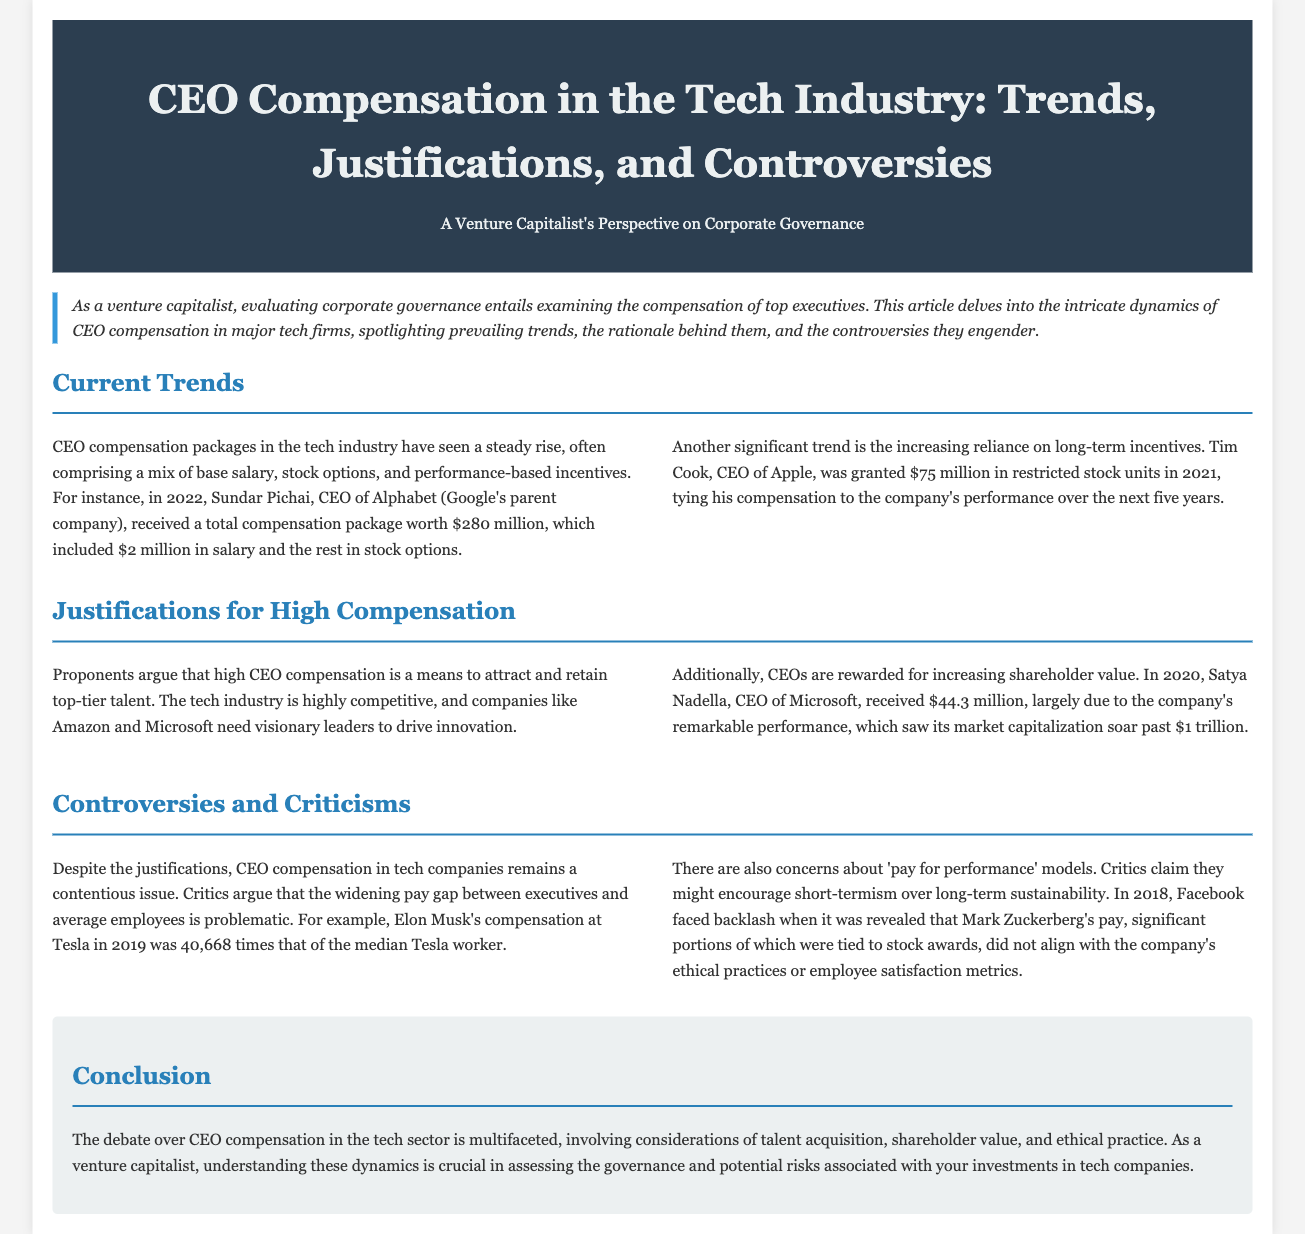What was Sundar Pichai's total compensation in 2022? Sundar Pichai's total compensation included $2 million in salary and the rest in stock options, totaling $280 million.
Answer: $280 million How much was Tim Cook's restricted stock units grant in 2021? Tim Cook was granted $75 million in restricted stock units in 2021.
Answer: $75 million What is the ratio of Elon Musk's compensation to the median Tesla worker's pay in 2019? Elon Musk's compensation was 40,668 times that of the median Tesla worker.
Answer: 40,668 times What performance did Satya Nadella achieve to receive his compensation? Satya Nadella's compensation was largely due to Microsoft's remarkable performance, as its market capitalization soared past $1 trillion.
Answer: Market capitalization surpassed $1 trillion Why do proponents justify high CEO compensation? Proponents argue high CEO compensation is to attract and retain top-tier talent in a competitive tech industry.
Answer: Attract and retain top-tier talent What criticism is made against 'pay for performance' models? Critics claim 'pay for performance' models might encourage short-termism over long-term sustainability.
Answer: Short-termism What is the article's main focus regarding tech companies? The article delves into CEO compensation dynamics, including trends, justifications, and controversies.
Answer: CEO compensation dynamics What type of format is this document presented in? The document is presented in a newspaper layout that features sections and headings.
Answer: Newspaper layout 